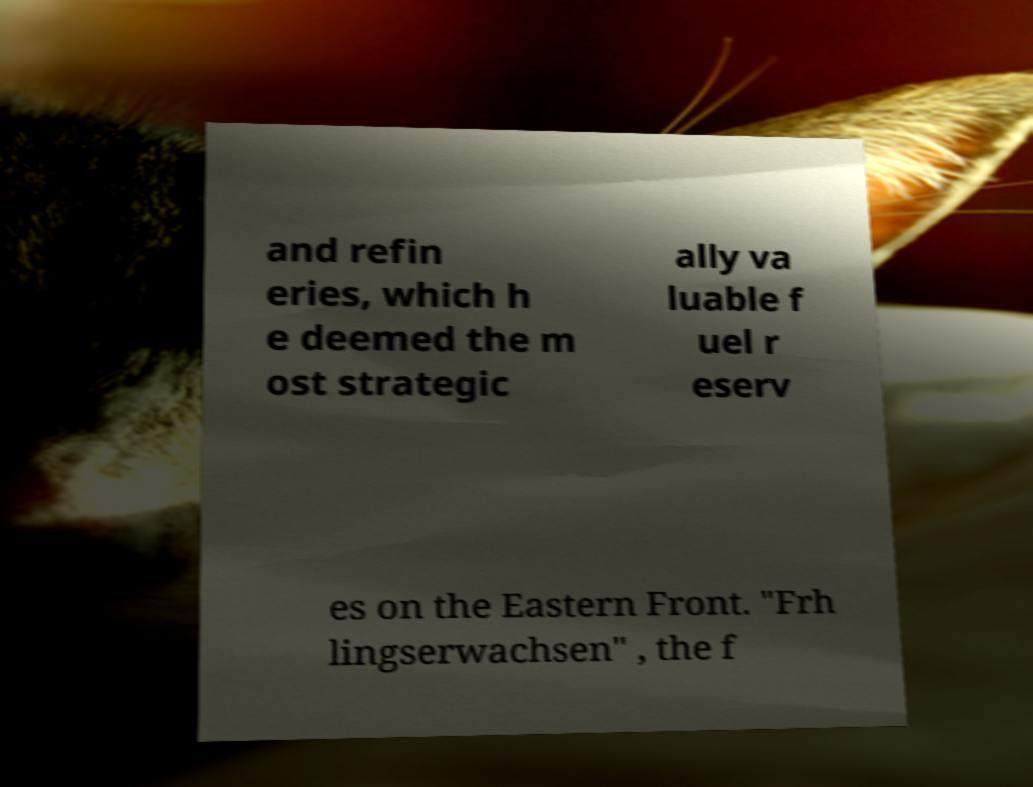There's text embedded in this image that I need extracted. Can you transcribe it verbatim? and refin eries, which h e deemed the m ost strategic ally va luable f uel r eserv es on the Eastern Front. "Frh lingserwachsen" , the f 